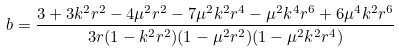<formula> <loc_0><loc_0><loc_500><loc_500>b = \frac { 3 + 3 k ^ { 2 } r ^ { 2 } - 4 \mu ^ { 2 } r ^ { 2 } - 7 \mu ^ { 2 } k ^ { 2 } r ^ { 4 } - \mu ^ { 2 } k ^ { 4 } r ^ { 6 } + 6 \mu ^ { 4 } k ^ { 2 } r ^ { 6 } } { 3 r ( 1 - k ^ { 2 } r ^ { 2 } ) ( 1 - \mu ^ { 2 } r ^ { 2 } ) ( 1 - \mu ^ { 2 } k ^ { 2 } r ^ { 4 } ) }</formula> 